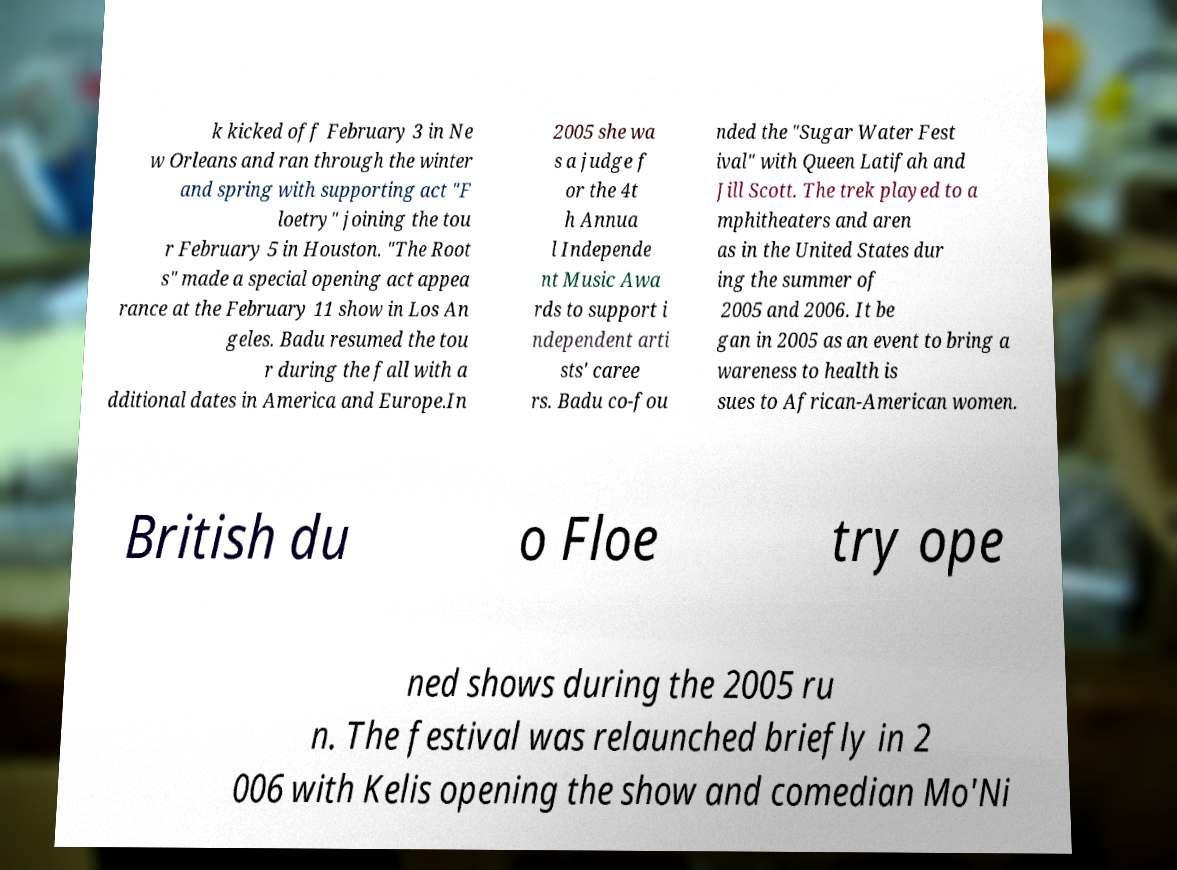I need the written content from this picture converted into text. Can you do that? k kicked off February 3 in Ne w Orleans and ran through the winter and spring with supporting act "F loetry" joining the tou r February 5 in Houston. "The Root s" made a special opening act appea rance at the February 11 show in Los An geles. Badu resumed the tou r during the fall with a dditional dates in America and Europe.In 2005 she wa s a judge f or the 4t h Annua l Independe nt Music Awa rds to support i ndependent arti sts' caree rs. Badu co-fou nded the "Sugar Water Fest ival" with Queen Latifah and Jill Scott. The trek played to a mphitheaters and aren as in the United States dur ing the summer of 2005 and 2006. It be gan in 2005 as an event to bring a wareness to health is sues to African-American women. British du o Floe try ope ned shows during the 2005 ru n. The festival was relaunched briefly in 2 006 with Kelis opening the show and comedian Mo'Ni 